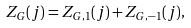Convert formula to latex. <formula><loc_0><loc_0><loc_500><loc_500>Z _ { G } ( j ) = Z _ { G , 1 } ( j ) + Z _ { G , - 1 } ( j ) ,</formula> 